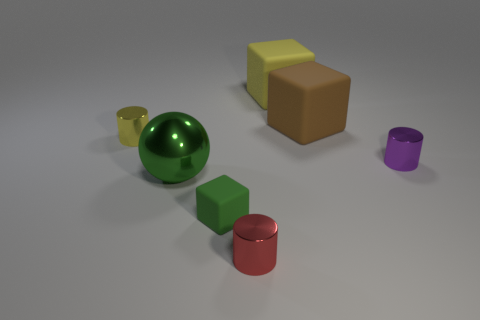Do the yellow rubber object and the small green object have the same shape?
Your answer should be very brief. Yes. How big is the sphere that is right of the small metallic object to the left of the small cylinder that is in front of the tiny green block?
Make the answer very short. Large. What is the material of the yellow thing that is the same shape as the tiny red metal object?
Provide a succinct answer. Metal. There is a yellow matte object that is behind the block that is in front of the big brown thing; what is its size?
Your response must be concise. Large. What is the color of the small rubber object?
Provide a succinct answer. Green. What number of shiny cylinders are in front of the small shiny cylinder left of the green rubber object?
Your answer should be compact. 2. There is a small metal object that is in front of the large green sphere; are there any rubber things in front of it?
Ensure brevity in your answer.  No. There is a red shiny cylinder; are there any small things to the left of it?
Offer a terse response. Yes. Do the tiny metal thing that is in front of the small rubber cube and the small yellow object have the same shape?
Your response must be concise. Yes. How many large green shiny objects have the same shape as the small green thing?
Your response must be concise. 0. 